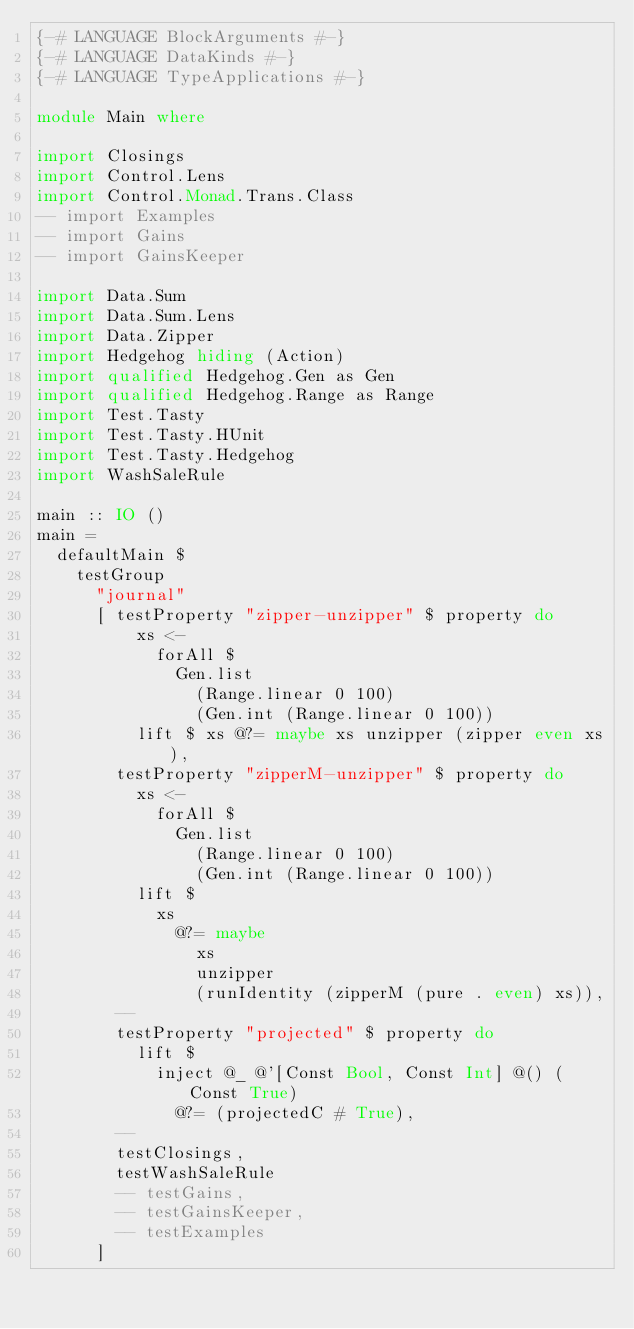<code> <loc_0><loc_0><loc_500><loc_500><_Haskell_>{-# LANGUAGE BlockArguments #-}
{-# LANGUAGE DataKinds #-}
{-# LANGUAGE TypeApplications #-}

module Main where

import Closings
import Control.Lens
import Control.Monad.Trans.Class
-- import Examples
-- import Gains
-- import GainsKeeper

import Data.Sum
import Data.Sum.Lens
import Data.Zipper
import Hedgehog hiding (Action)
import qualified Hedgehog.Gen as Gen
import qualified Hedgehog.Range as Range
import Test.Tasty
import Test.Tasty.HUnit
import Test.Tasty.Hedgehog
import WashSaleRule

main :: IO ()
main =
  defaultMain $
    testGroup
      "journal"
      [ testProperty "zipper-unzipper" $ property do
          xs <-
            forAll $
              Gen.list
                (Range.linear 0 100)
                (Gen.int (Range.linear 0 100))
          lift $ xs @?= maybe xs unzipper (zipper even xs),
        testProperty "zipperM-unzipper" $ property do
          xs <-
            forAll $
              Gen.list
                (Range.linear 0 100)
                (Gen.int (Range.linear 0 100))
          lift $
            xs
              @?= maybe
                xs
                unzipper
                (runIdentity (zipperM (pure . even) xs)),
        --
        testProperty "projected" $ property do
          lift $
            inject @_ @'[Const Bool, Const Int] @() (Const True)
              @?= (projectedC # True),
        --
        testClosings,
        testWashSaleRule
        -- testGains,
        -- testGainsKeeper,
        -- testExamples
      ]
</code> 